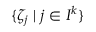Convert formula to latex. <formula><loc_0><loc_0><loc_500><loc_500>\{ \zeta _ { j } \, | \, j \in I ^ { k } \}</formula> 